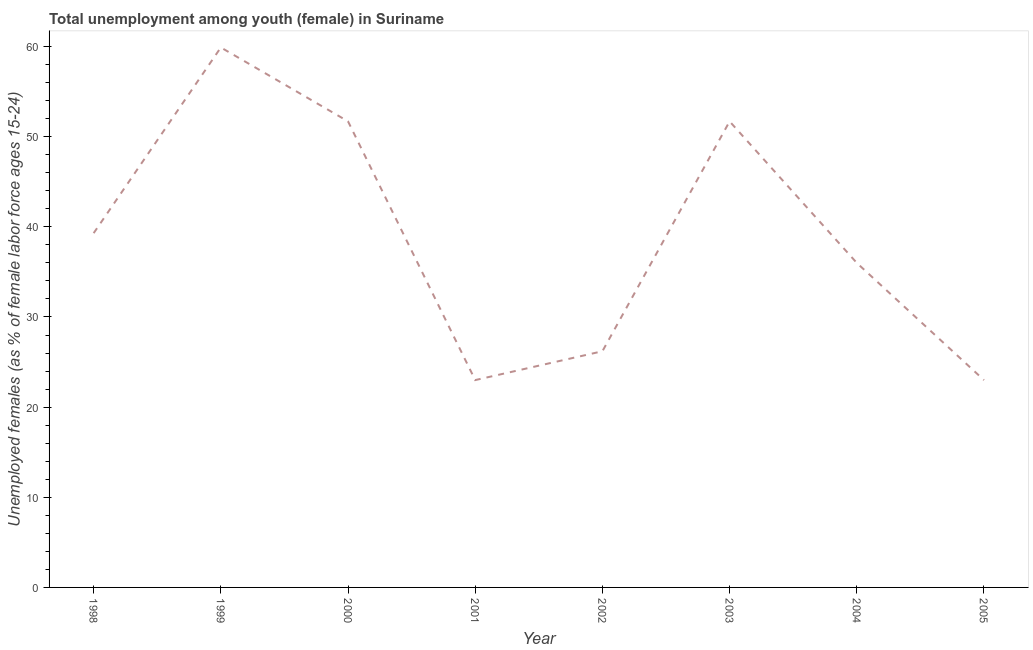What is the unemployed female youth population in 1998?
Make the answer very short. 39.3. Across all years, what is the maximum unemployed female youth population?
Ensure brevity in your answer.  59.9. Across all years, what is the minimum unemployed female youth population?
Give a very brief answer. 23. In which year was the unemployed female youth population maximum?
Provide a short and direct response. 1999. In which year was the unemployed female youth population minimum?
Provide a short and direct response. 2001. What is the sum of the unemployed female youth population?
Offer a very short reply. 310.8. What is the difference between the unemployed female youth population in 1998 and 2003?
Your answer should be compact. -12.4. What is the average unemployed female youth population per year?
Your answer should be very brief. 38.85. What is the median unemployed female youth population?
Give a very brief answer. 37.65. In how many years, is the unemployed female youth population greater than 20 %?
Your response must be concise. 8. What is the ratio of the unemployed female youth population in 2001 to that in 2003?
Offer a terse response. 0.44. Is the unemployed female youth population in 2002 less than that in 2003?
Ensure brevity in your answer.  Yes. What is the difference between the highest and the second highest unemployed female youth population?
Offer a terse response. 8.2. Is the sum of the unemployed female youth population in 2001 and 2004 greater than the maximum unemployed female youth population across all years?
Keep it short and to the point. No. What is the difference between the highest and the lowest unemployed female youth population?
Give a very brief answer. 36.9. How many years are there in the graph?
Your response must be concise. 8. What is the difference between two consecutive major ticks on the Y-axis?
Make the answer very short. 10. What is the title of the graph?
Ensure brevity in your answer.  Total unemployment among youth (female) in Suriname. What is the label or title of the X-axis?
Provide a succinct answer. Year. What is the label or title of the Y-axis?
Offer a very short reply. Unemployed females (as % of female labor force ages 15-24). What is the Unemployed females (as % of female labor force ages 15-24) of 1998?
Offer a terse response. 39.3. What is the Unemployed females (as % of female labor force ages 15-24) of 1999?
Offer a terse response. 59.9. What is the Unemployed females (as % of female labor force ages 15-24) in 2000?
Make the answer very short. 51.7. What is the Unemployed females (as % of female labor force ages 15-24) of 2002?
Keep it short and to the point. 26.2. What is the Unemployed females (as % of female labor force ages 15-24) of 2003?
Your answer should be very brief. 51.7. What is the Unemployed females (as % of female labor force ages 15-24) in 2004?
Your answer should be very brief. 36. What is the Unemployed females (as % of female labor force ages 15-24) of 2005?
Keep it short and to the point. 23. What is the difference between the Unemployed females (as % of female labor force ages 15-24) in 1998 and 1999?
Your answer should be very brief. -20.6. What is the difference between the Unemployed females (as % of female labor force ages 15-24) in 1998 and 2002?
Give a very brief answer. 13.1. What is the difference between the Unemployed females (as % of female labor force ages 15-24) in 1998 and 2003?
Your answer should be compact. -12.4. What is the difference between the Unemployed females (as % of female labor force ages 15-24) in 1998 and 2004?
Offer a very short reply. 3.3. What is the difference between the Unemployed females (as % of female labor force ages 15-24) in 1999 and 2000?
Make the answer very short. 8.2. What is the difference between the Unemployed females (as % of female labor force ages 15-24) in 1999 and 2001?
Make the answer very short. 36.9. What is the difference between the Unemployed females (as % of female labor force ages 15-24) in 1999 and 2002?
Your answer should be compact. 33.7. What is the difference between the Unemployed females (as % of female labor force ages 15-24) in 1999 and 2004?
Your answer should be very brief. 23.9. What is the difference between the Unemployed females (as % of female labor force ages 15-24) in 1999 and 2005?
Offer a very short reply. 36.9. What is the difference between the Unemployed females (as % of female labor force ages 15-24) in 2000 and 2001?
Offer a terse response. 28.7. What is the difference between the Unemployed females (as % of female labor force ages 15-24) in 2000 and 2004?
Provide a short and direct response. 15.7. What is the difference between the Unemployed females (as % of female labor force ages 15-24) in 2000 and 2005?
Provide a short and direct response. 28.7. What is the difference between the Unemployed females (as % of female labor force ages 15-24) in 2001 and 2002?
Offer a terse response. -3.2. What is the difference between the Unemployed females (as % of female labor force ages 15-24) in 2001 and 2003?
Offer a terse response. -28.7. What is the difference between the Unemployed females (as % of female labor force ages 15-24) in 2001 and 2004?
Your answer should be compact. -13. What is the difference between the Unemployed females (as % of female labor force ages 15-24) in 2002 and 2003?
Offer a very short reply. -25.5. What is the difference between the Unemployed females (as % of female labor force ages 15-24) in 2002 and 2004?
Your answer should be very brief. -9.8. What is the difference between the Unemployed females (as % of female labor force ages 15-24) in 2003 and 2004?
Keep it short and to the point. 15.7. What is the difference between the Unemployed females (as % of female labor force ages 15-24) in 2003 and 2005?
Make the answer very short. 28.7. What is the ratio of the Unemployed females (as % of female labor force ages 15-24) in 1998 to that in 1999?
Provide a succinct answer. 0.66. What is the ratio of the Unemployed females (as % of female labor force ages 15-24) in 1998 to that in 2000?
Your answer should be very brief. 0.76. What is the ratio of the Unemployed females (as % of female labor force ages 15-24) in 1998 to that in 2001?
Provide a succinct answer. 1.71. What is the ratio of the Unemployed females (as % of female labor force ages 15-24) in 1998 to that in 2003?
Ensure brevity in your answer.  0.76. What is the ratio of the Unemployed females (as % of female labor force ages 15-24) in 1998 to that in 2004?
Ensure brevity in your answer.  1.09. What is the ratio of the Unemployed females (as % of female labor force ages 15-24) in 1998 to that in 2005?
Ensure brevity in your answer.  1.71. What is the ratio of the Unemployed females (as % of female labor force ages 15-24) in 1999 to that in 2000?
Offer a very short reply. 1.16. What is the ratio of the Unemployed females (as % of female labor force ages 15-24) in 1999 to that in 2001?
Provide a short and direct response. 2.6. What is the ratio of the Unemployed females (as % of female labor force ages 15-24) in 1999 to that in 2002?
Offer a very short reply. 2.29. What is the ratio of the Unemployed females (as % of female labor force ages 15-24) in 1999 to that in 2003?
Your response must be concise. 1.16. What is the ratio of the Unemployed females (as % of female labor force ages 15-24) in 1999 to that in 2004?
Ensure brevity in your answer.  1.66. What is the ratio of the Unemployed females (as % of female labor force ages 15-24) in 1999 to that in 2005?
Your answer should be very brief. 2.6. What is the ratio of the Unemployed females (as % of female labor force ages 15-24) in 2000 to that in 2001?
Ensure brevity in your answer.  2.25. What is the ratio of the Unemployed females (as % of female labor force ages 15-24) in 2000 to that in 2002?
Make the answer very short. 1.97. What is the ratio of the Unemployed females (as % of female labor force ages 15-24) in 2000 to that in 2003?
Your answer should be very brief. 1. What is the ratio of the Unemployed females (as % of female labor force ages 15-24) in 2000 to that in 2004?
Your answer should be compact. 1.44. What is the ratio of the Unemployed females (as % of female labor force ages 15-24) in 2000 to that in 2005?
Your answer should be very brief. 2.25. What is the ratio of the Unemployed females (as % of female labor force ages 15-24) in 2001 to that in 2002?
Make the answer very short. 0.88. What is the ratio of the Unemployed females (as % of female labor force ages 15-24) in 2001 to that in 2003?
Provide a succinct answer. 0.45. What is the ratio of the Unemployed females (as % of female labor force ages 15-24) in 2001 to that in 2004?
Make the answer very short. 0.64. What is the ratio of the Unemployed females (as % of female labor force ages 15-24) in 2002 to that in 2003?
Give a very brief answer. 0.51. What is the ratio of the Unemployed females (as % of female labor force ages 15-24) in 2002 to that in 2004?
Make the answer very short. 0.73. What is the ratio of the Unemployed females (as % of female labor force ages 15-24) in 2002 to that in 2005?
Your answer should be compact. 1.14. What is the ratio of the Unemployed females (as % of female labor force ages 15-24) in 2003 to that in 2004?
Offer a terse response. 1.44. What is the ratio of the Unemployed females (as % of female labor force ages 15-24) in 2003 to that in 2005?
Your response must be concise. 2.25. What is the ratio of the Unemployed females (as % of female labor force ages 15-24) in 2004 to that in 2005?
Offer a very short reply. 1.56. 